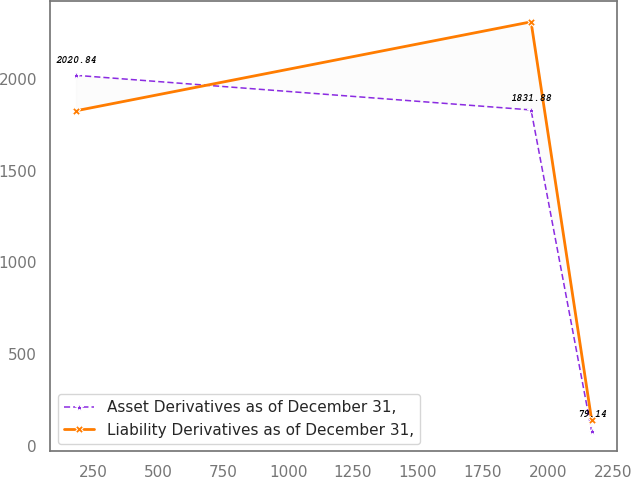Convert chart. <chart><loc_0><loc_0><loc_500><loc_500><line_chart><ecel><fcel>Asset Derivatives as of December 31,<fcel>Liability Derivatives as of December 31,<nl><fcel>183.17<fcel>2020.84<fcel>1827.3<nl><fcel>1935.6<fcel>1831.88<fcel>2312.77<nl><fcel>2168.77<fcel>79.14<fcel>140.67<nl></chart> 